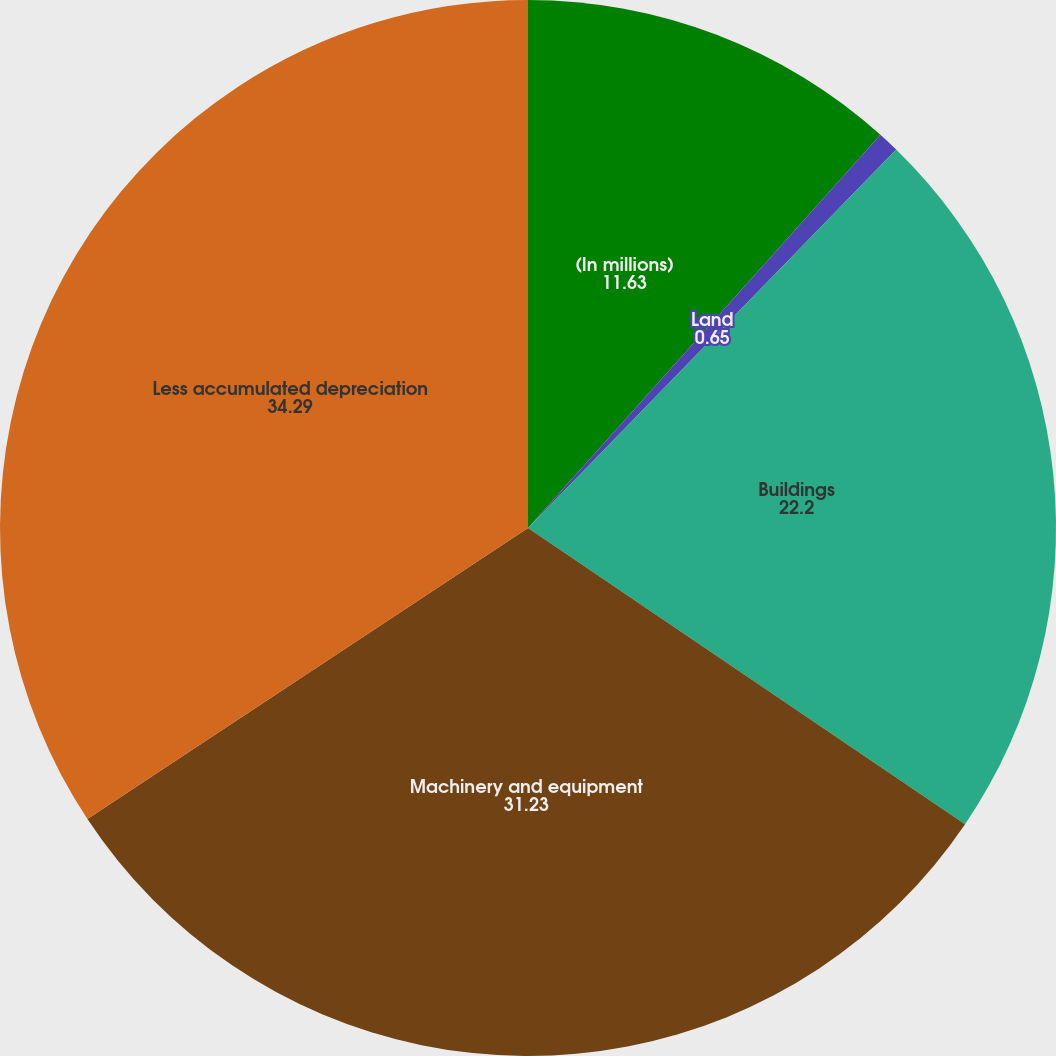<chart> <loc_0><loc_0><loc_500><loc_500><pie_chart><fcel>(In millions)<fcel>Land<fcel>Buildings<fcel>Machinery and equipment<fcel>Less accumulated depreciation<nl><fcel>11.63%<fcel>0.65%<fcel>22.2%<fcel>31.23%<fcel>34.29%<nl></chart> 